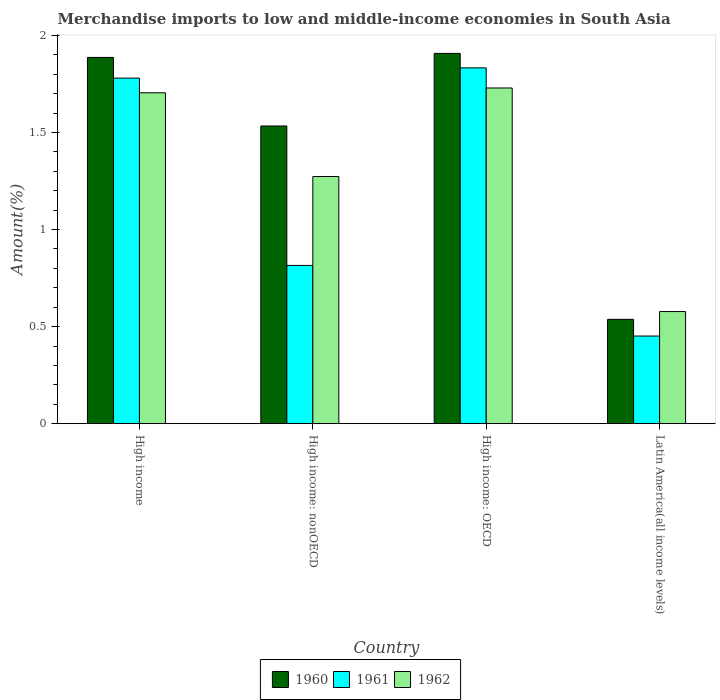How many different coloured bars are there?
Ensure brevity in your answer.  3. How many groups of bars are there?
Ensure brevity in your answer.  4. Are the number of bars on each tick of the X-axis equal?
Your response must be concise. Yes. How many bars are there on the 1st tick from the left?
Your answer should be compact. 3. How many bars are there on the 1st tick from the right?
Provide a succinct answer. 3. What is the percentage of amount earned from merchandise imports in 1961 in High income: OECD?
Your response must be concise. 1.83. Across all countries, what is the maximum percentage of amount earned from merchandise imports in 1961?
Your answer should be compact. 1.83. Across all countries, what is the minimum percentage of amount earned from merchandise imports in 1960?
Ensure brevity in your answer.  0.54. In which country was the percentage of amount earned from merchandise imports in 1960 maximum?
Ensure brevity in your answer.  High income: OECD. In which country was the percentage of amount earned from merchandise imports in 1962 minimum?
Offer a terse response. Latin America(all income levels). What is the total percentage of amount earned from merchandise imports in 1960 in the graph?
Provide a short and direct response. 5.86. What is the difference between the percentage of amount earned from merchandise imports in 1960 in High income: nonOECD and that in Latin America(all income levels)?
Your response must be concise. 1. What is the difference between the percentage of amount earned from merchandise imports in 1961 in High income and the percentage of amount earned from merchandise imports in 1962 in High income: OECD?
Give a very brief answer. 0.05. What is the average percentage of amount earned from merchandise imports in 1961 per country?
Give a very brief answer. 1.22. What is the difference between the percentage of amount earned from merchandise imports of/in 1960 and percentage of amount earned from merchandise imports of/in 1962 in High income: nonOECD?
Make the answer very short. 0.26. In how many countries, is the percentage of amount earned from merchandise imports in 1960 greater than 1.2 %?
Provide a succinct answer. 3. What is the ratio of the percentage of amount earned from merchandise imports in 1960 in High income: nonOECD to that in Latin America(all income levels)?
Your response must be concise. 2.85. Is the difference between the percentage of amount earned from merchandise imports in 1960 in High income: OECD and High income: nonOECD greater than the difference between the percentage of amount earned from merchandise imports in 1962 in High income: OECD and High income: nonOECD?
Give a very brief answer. No. What is the difference between the highest and the second highest percentage of amount earned from merchandise imports in 1961?
Your answer should be compact. -1.02. What is the difference between the highest and the lowest percentage of amount earned from merchandise imports in 1960?
Offer a terse response. 1.37. Is the sum of the percentage of amount earned from merchandise imports in 1962 in High income: nonOECD and Latin America(all income levels) greater than the maximum percentage of amount earned from merchandise imports in 1961 across all countries?
Offer a terse response. Yes. What does the 1st bar from the left in High income: OECD represents?
Your answer should be compact. 1960. What does the 1st bar from the right in High income represents?
Your answer should be compact. 1962. How many bars are there?
Your answer should be compact. 12. Are all the bars in the graph horizontal?
Ensure brevity in your answer.  No. Does the graph contain grids?
Your answer should be compact. No. How many legend labels are there?
Your response must be concise. 3. What is the title of the graph?
Your response must be concise. Merchandise imports to low and middle-income economies in South Asia. What is the label or title of the Y-axis?
Give a very brief answer. Amount(%). What is the Amount(%) of 1960 in High income?
Keep it short and to the point. 1.89. What is the Amount(%) of 1961 in High income?
Provide a succinct answer. 1.78. What is the Amount(%) of 1962 in High income?
Your response must be concise. 1.7. What is the Amount(%) in 1960 in High income: nonOECD?
Your answer should be very brief. 1.53. What is the Amount(%) of 1961 in High income: nonOECD?
Provide a short and direct response. 0.82. What is the Amount(%) in 1962 in High income: nonOECD?
Your answer should be compact. 1.27. What is the Amount(%) of 1960 in High income: OECD?
Offer a very short reply. 1.91. What is the Amount(%) of 1961 in High income: OECD?
Provide a succinct answer. 1.83. What is the Amount(%) in 1962 in High income: OECD?
Make the answer very short. 1.73. What is the Amount(%) of 1960 in Latin America(all income levels)?
Offer a very short reply. 0.54. What is the Amount(%) in 1961 in Latin America(all income levels)?
Provide a succinct answer. 0.45. What is the Amount(%) in 1962 in Latin America(all income levels)?
Offer a terse response. 0.58. Across all countries, what is the maximum Amount(%) of 1960?
Keep it short and to the point. 1.91. Across all countries, what is the maximum Amount(%) in 1961?
Provide a short and direct response. 1.83. Across all countries, what is the maximum Amount(%) in 1962?
Keep it short and to the point. 1.73. Across all countries, what is the minimum Amount(%) of 1960?
Offer a very short reply. 0.54. Across all countries, what is the minimum Amount(%) in 1961?
Provide a short and direct response. 0.45. Across all countries, what is the minimum Amount(%) of 1962?
Provide a short and direct response. 0.58. What is the total Amount(%) of 1960 in the graph?
Offer a very short reply. 5.86. What is the total Amount(%) in 1961 in the graph?
Provide a short and direct response. 4.88. What is the total Amount(%) in 1962 in the graph?
Your answer should be very brief. 5.28. What is the difference between the Amount(%) in 1960 in High income and that in High income: nonOECD?
Keep it short and to the point. 0.35. What is the difference between the Amount(%) of 1961 in High income and that in High income: nonOECD?
Provide a short and direct response. 0.96. What is the difference between the Amount(%) in 1962 in High income and that in High income: nonOECD?
Make the answer very short. 0.43. What is the difference between the Amount(%) in 1960 in High income and that in High income: OECD?
Make the answer very short. -0.02. What is the difference between the Amount(%) in 1961 in High income and that in High income: OECD?
Provide a succinct answer. -0.05. What is the difference between the Amount(%) of 1962 in High income and that in High income: OECD?
Offer a terse response. -0.02. What is the difference between the Amount(%) in 1960 in High income and that in Latin America(all income levels)?
Make the answer very short. 1.35. What is the difference between the Amount(%) of 1961 in High income and that in Latin America(all income levels)?
Provide a succinct answer. 1.33. What is the difference between the Amount(%) of 1962 in High income and that in Latin America(all income levels)?
Give a very brief answer. 1.13. What is the difference between the Amount(%) of 1960 in High income: nonOECD and that in High income: OECD?
Give a very brief answer. -0.37. What is the difference between the Amount(%) of 1961 in High income: nonOECD and that in High income: OECD?
Your answer should be very brief. -1.02. What is the difference between the Amount(%) of 1962 in High income: nonOECD and that in High income: OECD?
Give a very brief answer. -0.46. What is the difference between the Amount(%) in 1960 in High income: nonOECD and that in Latin America(all income levels)?
Your answer should be very brief. 1. What is the difference between the Amount(%) in 1961 in High income: nonOECD and that in Latin America(all income levels)?
Provide a succinct answer. 0.36. What is the difference between the Amount(%) of 1962 in High income: nonOECD and that in Latin America(all income levels)?
Give a very brief answer. 0.7. What is the difference between the Amount(%) of 1960 in High income: OECD and that in Latin America(all income levels)?
Offer a terse response. 1.37. What is the difference between the Amount(%) in 1961 in High income: OECD and that in Latin America(all income levels)?
Offer a very short reply. 1.38. What is the difference between the Amount(%) of 1962 in High income: OECD and that in Latin America(all income levels)?
Your answer should be compact. 1.15. What is the difference between the Amount(%) in 1960 in High income and the Amount(%) in 1961 in High income: nonOECD?
Provide a succinct answer. 1.07. What is the difference between the Amount(%) in 1960 in High income and the Amount(%) in 1962 in High income: nonOECD?
Offer a very short reply. 0.61. What is the difference between the Amount(%) in 1961 in High income and the Amount(%) in 1962 in High income: nonOECD?
Your answer should be very brief. 0.51. What is the difference between the Amount(%) of 1960 in High income and the Amount(%) of 1961 in High income: OECD?
Keep it short and to the point. 0.05. What is the difference between the Amount(%) in 1960 in High income and the Amount(%) in 1962 in High income: OECD?
Make the answer very short. 0.16. What is the difference between the Amount(%) in 1961 in High income and the Amount(%) in 1962 in High income: OECD?
Ensure brevity in your answer.  0.05. What is the difference between the Amount(%) of 1960 in High income and the Amount(%) of 1961 in Latin America(all income levels)?
Your response must be concise. 1.43. What is the difference between the Amount(%) of 1960 in High income and the Amount(%) of 1962 in Latin America(all income levels)?
Give a very brief answer. 1.31. What is the difference between the Amount(%) in 1961 in High income and the Amount(%) in 1962 in Latin America(all income levels)?
Offer a terse response. 1.2. What is the difference between the Amount(%) in 1960 in High income: nonOECD and the Amount(%) in 1961 in High income: OECD?
Give a very brief answer. -0.3. What is the difference between the Amount(%) of 1960 in High income: nonOECD and the Amount(%) of 1962 in High income: OECD?
Give a very brief answer. -0.2. What is the difference between the Amount(%) of 1961 in High income: nonOECD and the Amount(%) of 1962 in High income: OECD?
Make the answer very short. -0.91. What is the difference between the Amount(%) of 1960 in High income: nonOECD and the Amount(%) of 1961 in Latin America(all income levels)?
Provide a short and direct response. 1.08. What is the difference between the Amount(%) in 1960 in High income: nonOECD and the Amount(%) in 1962 in Latin America(all income levels)?
Give a very brief answer. 0.96. What is the difference between the Amount(%) in 1961 in High income: nonOECD and the Amount(%) in 1962 in Latin America(all income levels)?
Your answer should be compact. 0.24. What is the difference between the Amount(%) in 1960 in High income: OECD and the Amount(%) in 1961 in Latin America(all income levels)?
Your answer should be very brief. 1.46. What is the difference between the Amount(%) of 1960 in High income: OECD and the Amount(%) of 1962 in Latin America(all income levels)?
Your answer should be compact. 1.33. What is the difference between the Amount(%) of 1961 in High income: OECD and the Amount(%) of 1962 in Latin America(all income levels)?
Your answer should be compact. 1.25. What is the average Amount(%) of 1960 per country?
Offer a very short reply. 1.47. What is the average Amount(%) in 1961 per country?
Provide a succinct answer. 1.22. What is the average Amount(%) in 1962 per country?
Your answer should be very brief. 1.32. What is the difference between the Amount(%) in 1960 and Amount(%) in 1961 in High income?
Your answer should be compact. 0.11. What is the difference between the Amount(%) in 1960 and Amount(%) in 1962 in High income?
Your response must be concise. 0.18. What is the difference between the Amount(%) in 1961 and Amount(%) in 1962 in High income?
Your response must be concise. 0.08. What is the difference between the Amount(%) of 1960 and Amount(%) of 1961 in High income: nonOECD?
Provide a short and direct response. 0.72. What is the difference between the Amount(%) in 1960 and Amount(%) in 1962 in High income: nonOECD?
Keep it short and to the point. 0.26. What is the difference between the Amount(%) of 1961 and Amount(%) of 1962 in High income: nonOECD?
Make the answer very short. -0.46. What is the difference between the Amount(%) of 1960 and Amount(%) of 1961 in High income: OECD?
Your answer should be compact. 0.07. What is the difference between the Amount(%) of 1960 and Amount(%) of 1962 in High income: OECD?
Offer a very short reply. 0.18. What is the difference between the Amount(%) of 1961 and Amount(%) of 1962 in High income: OECD?
Provide a short and direct response. 0.1. What is the difference between the Amount(%) in 1960 and Amount(%) in 1961 in Latin America(all income levels)?
Your answer should be compact. 0.09. What is the difference between the Amount(%) in 1960 and Amount(%) in 1962 in Latin America(all income levels)?
Give a very brief answer. -0.04. What is the difference between the Amount(%) in 1961 and Amount(%) in 1962 in Latin America(all income levels)?
Give a very brief answer. -0.13. What is the ratio of the Amount(%) of 1960 in High income to that in High income: nonOECD?
Ensure brevity in your answer.  1.23. What is the ratio of the Amount(%) in 1961 in High income to that in High income: nonOECD?
Provide a short and direct response. 2.18. What is the ratio of the Amount(%) of 1962 in High income to that in High income: nonOECD?
Keep it short and to the point. 1.34. What is the ratio of the Amount(%) of 1960 in High income to that in High income: OECD?
Your answer should be very brief. 0.99. What is the ratio of the Amount(%) of 1961 in High income to that in High income: OECD?
Your response must be concise. 0.97. What is the ratio of the Amount(%) of 1962 in High income to that in High income: OECD?
Your answer should be compact. 0.99. What is the ratio of the Amount(%) in 1960 in High income to that in Latin America(all income levels)?
Your answer should be very brief. 3.51. What is the ratio of the Amount(%) in 1961 in High income to that in Latin America(all income levels)?
Your answer should be compact. 3.94. What is the ratio of the Amount(%) of 1962 in High income to that in Latin America(all income levels)?
Offer a very short reply. 2.95. What is the ratio of the Amount(%) in 1960 in High income: nonOECD to that in High income: OECD?
Your answer should be very brief. 0.8. What is the ratio of the Amount(%) in 1961 in High income: nonOECD to that in High income: OECD?
Your answer should be compact. 0.44. What is the ratio of the Amount(%) of 1962 in High income: nonOECD to that in High income: OECD?
Your answer should be compact. 0.74. What is the ratio of the Amount(%) in 1960 in High income: nonOECD to that in Latin America(all income levels)?
Make the answer very short. 2.85. What is the ratio of the Amount(%) in 1961 in High income: nonOECD to that in Latin America(all income levels)?
Your answer should be compact. 1.81. What is the ratio of the Amount(%) in 1962 in High income: nonOECD to that in Latin America(all income levels)?
Provide a succinct answer. 2.2. What is the ratio of the Amount(%) of 1960 in High income: OECD to that in Latin America(all income levels)?
Make the answer very short. 3.55. What is the ratio of the Amount(%) in 1961 in High income: OECD to that in Latin America(all income levels)?
Provide a succinct answer. 4.06. What is the ratio of the Amount(%) in 1962 in High income: OECD to that in Latin America(all income levels)?
Offer a terse response. 2.99. What is the difference between the highest and the second highest Amount(%) of 1960?
Give a very brief answer. 0.02. What is the difference between the highest and the second highest Amount(%) in 1961?
Keep it short and to the point. 0.05. What is the difference between the highest and the second highest Amount(%) of 1962?
Your answer should be compact. 0.02. What is the difference between the highest and the lowest Amount(%) in 1960?
Provide a short and direct response. 1.37. What is the difference between the highest and the lowest Amount(%) in 1961?
Your response must be concise. 1.38. What is the difference between the highest and the lowest Amount(%) in 1962?
Provide a succinct answer. 1.15. 